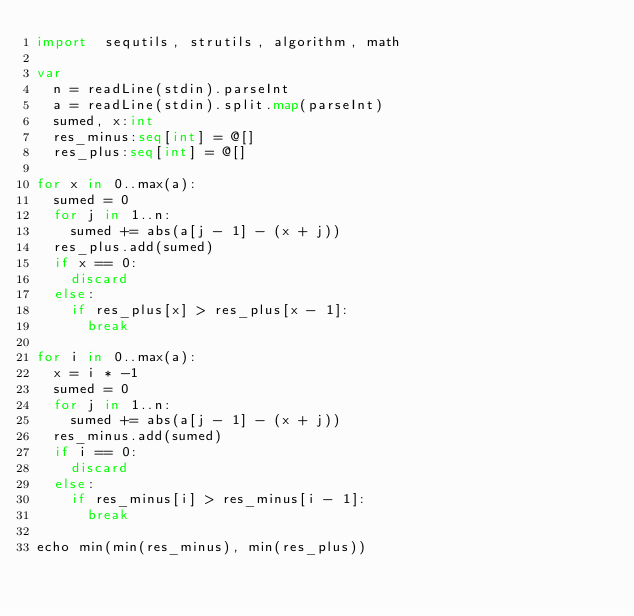<code> <loc_0><loc_0><loc_500><loc_500><_Nim_>import  sequtils, strutils, algorithm, math

var
  n = readLine(stdin).parseInt
  a = readLine(stdin).split.map(parseInt)
  sumed, x:int
  res_minus:seq[int] = @[]
  res_plus:seq[int] = @[]

for x in 0..max(a):
  sumed = 0
  for j in 1..n:
    sumed += abs(a[j - 1] - (x + j))
  res_plus.add(sumed)
  if x == 0:
    discard
  else:
    if res_plus[x] > res_plus[x - 1]:
      break

for i in 0..max(a):
  x = i * -1
  sumed = 0
  for j in 1..n:
    sumed += abs(a[j - 1] - (x + j))
  res_minus.add(sumed)
  if i == 0:
    discard
  else:
    if res_minus[i] > res_minus[i - 1]:
      break

echo min(min(res_minus), min(res_plus))</code> 